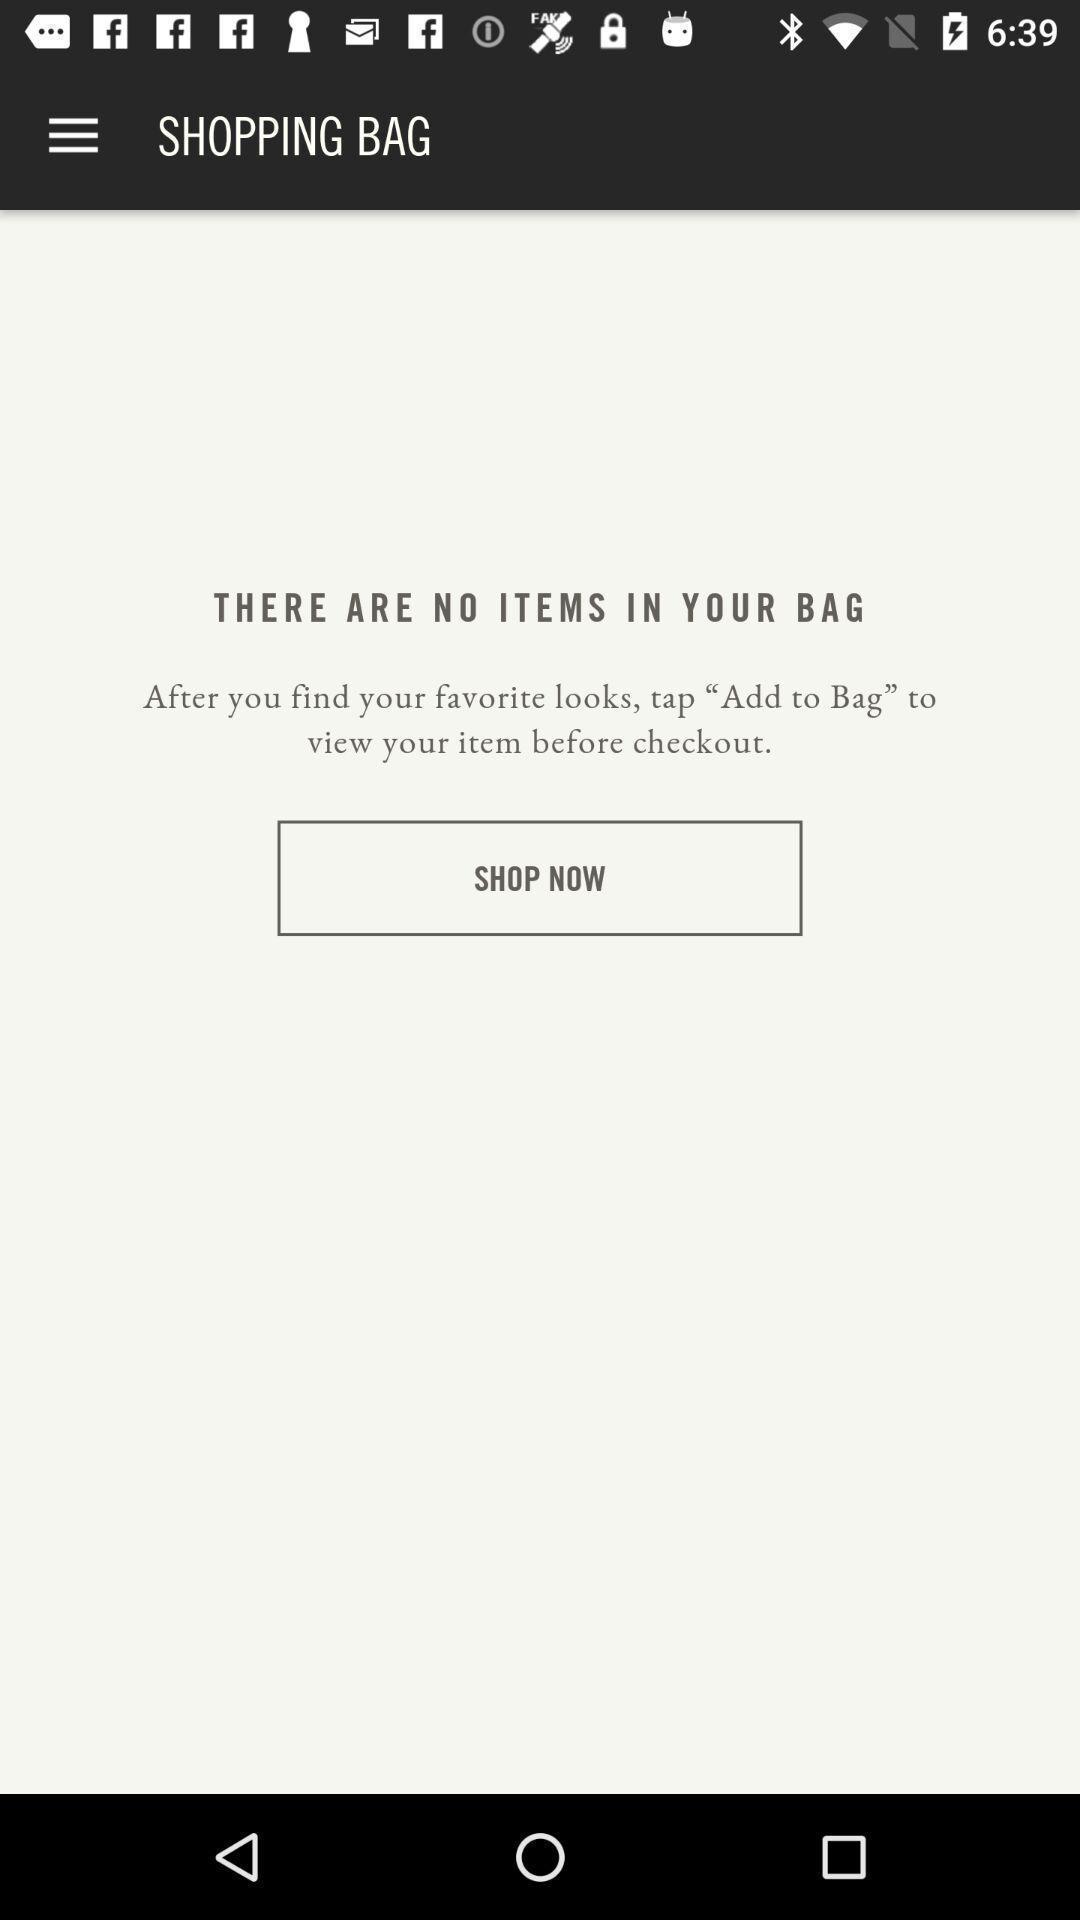Give me a narrative description of this picture. Shopping bag page of a shopping application. 